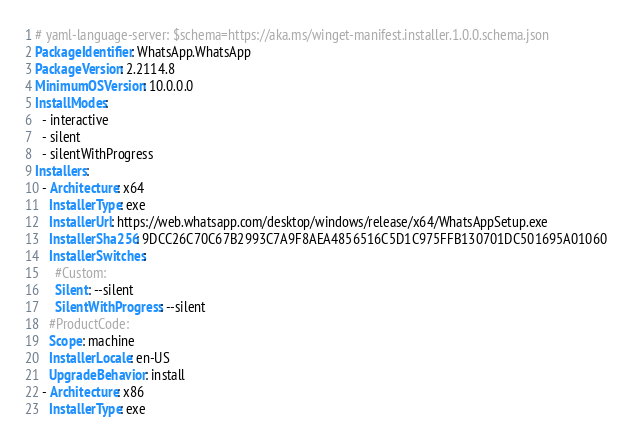Convert code to text. <code><loc_0><loc_0><loc_500><loc_500><_YAML_># yaml-language-server: $schema=https://aka.ms/winget-manifest.installer.1.0.0.schema.json
PackageIdentifier: WhatsApp.WhatsApp
PackageVersion: 2.2114.8
MinimumOSVersion: 10.0.0.0
InstallModes:
  - interactive
  - silent
  - silentWithProgress
Installers:
  - Architecture: x64
    InstallerType: exe
    InstallerUrl: https://web.whatsapp.com/desktop/windows/release/x64/WhatsAppSetup.exe
    InstallerSha256: 9DCC26C70C67B2993C7A9F8AEA4856516C5D1C975FFB130701DC501695A01060
    InstallerSwitches:
      #Custom: 
      Silent: --silent
      SilentWithProgress: --silent
    #ProductCode: 
    Scope: machine
    InstallerLocale: en-US
    UpgradeBehavior: install
  - Architecture: x86
    InstallerType: exe</code> 